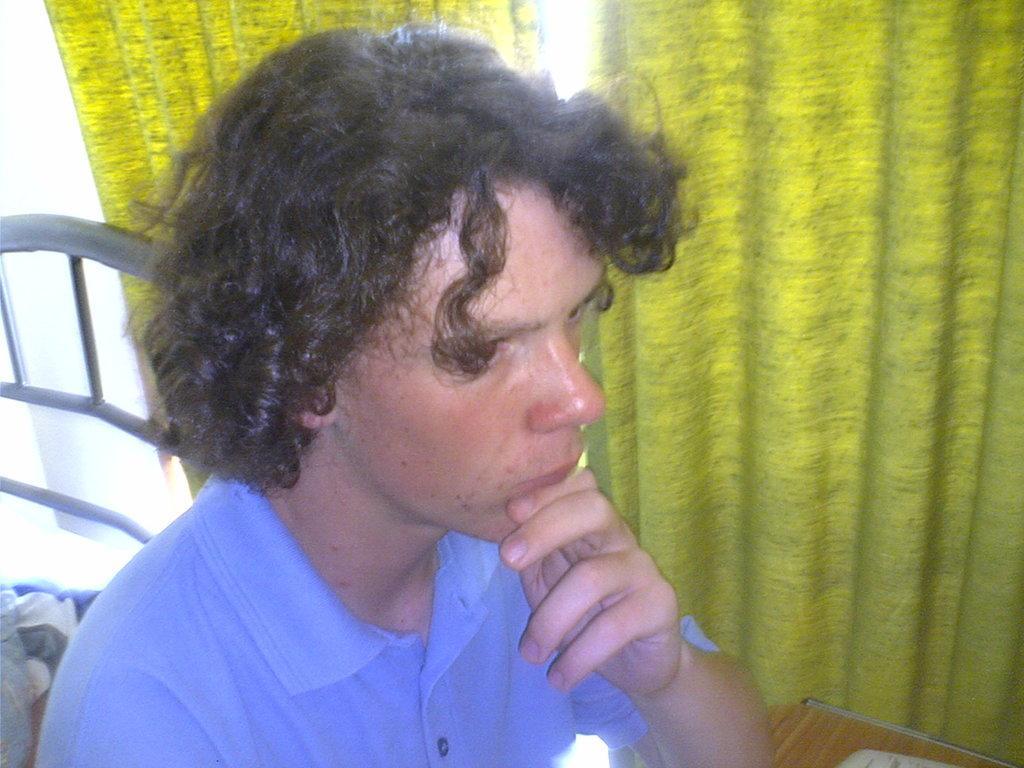Please provide a concise description of this image. In this picture we can see a person in the front, it looks like a table at the right bottom, there are curtains in the background. 